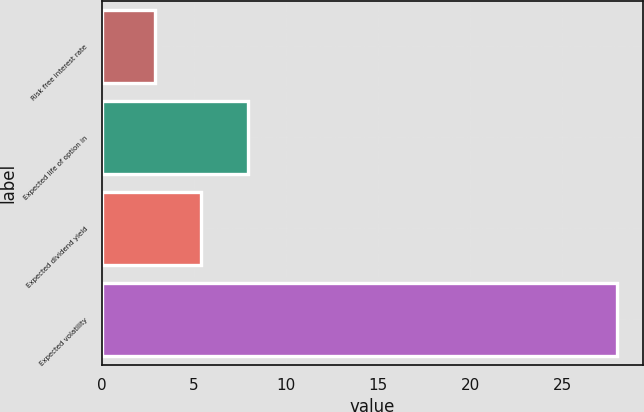Convert chart to OTSL. <chart><loc_0><loc_0><loc_500><loc_500><bar_chart><fcel>Risk free interest rate<fcel>Expected life of option in<fcel>Expected dividend yield<fcel>Expected volatility<nl><fcel>2.9<fcel>7.92<fcel>5.41<fcel>28<nl></chart> 